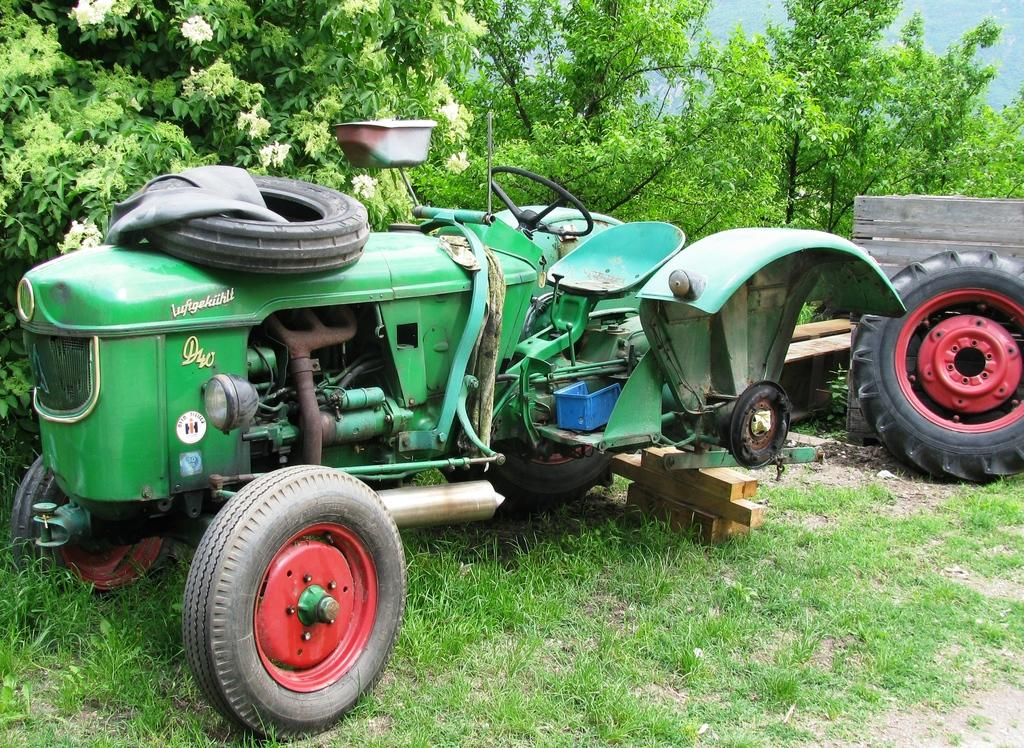What is the main subject of the image? There is a vehicle in the image. What type of terrain is visible in the image? There is grass visible in the image. What part of the vehicle is shown in the image? There is a tire in the image. What material is behind the tire? There is a wooden surface behind the tire. What can be seen in the distance in the image? There are trees and flowers in the background of the image. What type of haircut does the turkey have in the image? There is no turkey present in the image, so it is not possible to determine the type of haircut it might have. 